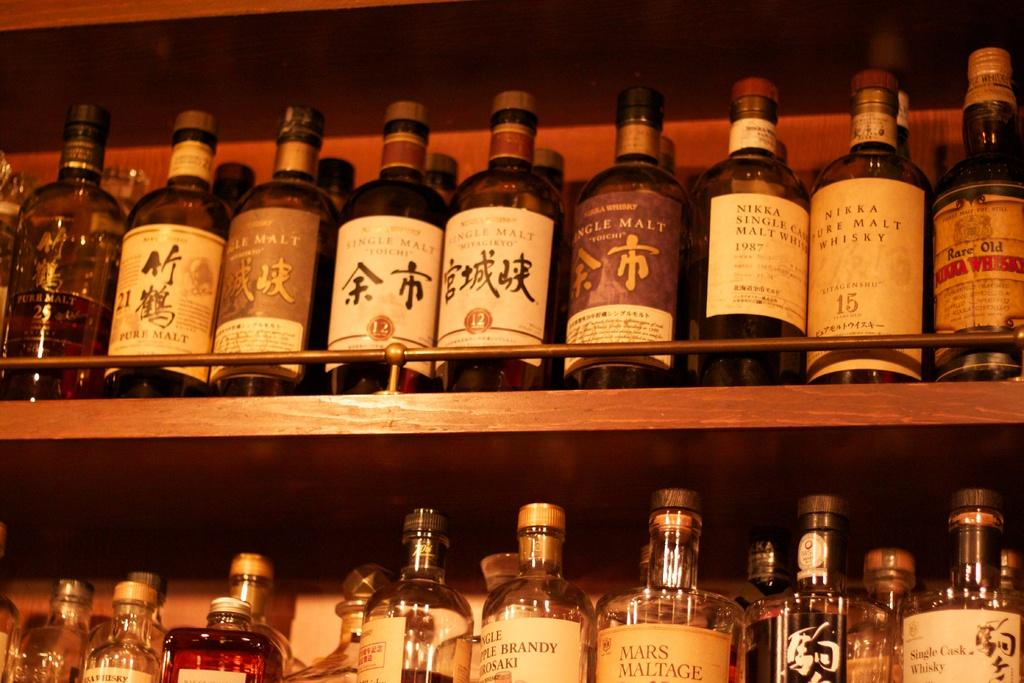<image>
Render a clear and concise summary of the photo. bottles of liquor on a bar include Single Malt Toiche 